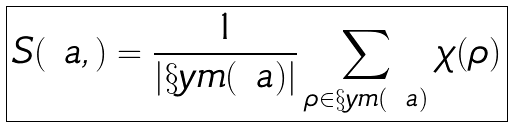Convert formula to latex. <formula><loc_0><loc_0><loc_500><loc_500>\boxed { S ( \ a , \L ) = \frac { 1 } { | \S y m ( \ a ) | } \sum _ { \rho \in \S y m ( \ a ) } \chi _ { \L } ( \rho ) }</formula> 